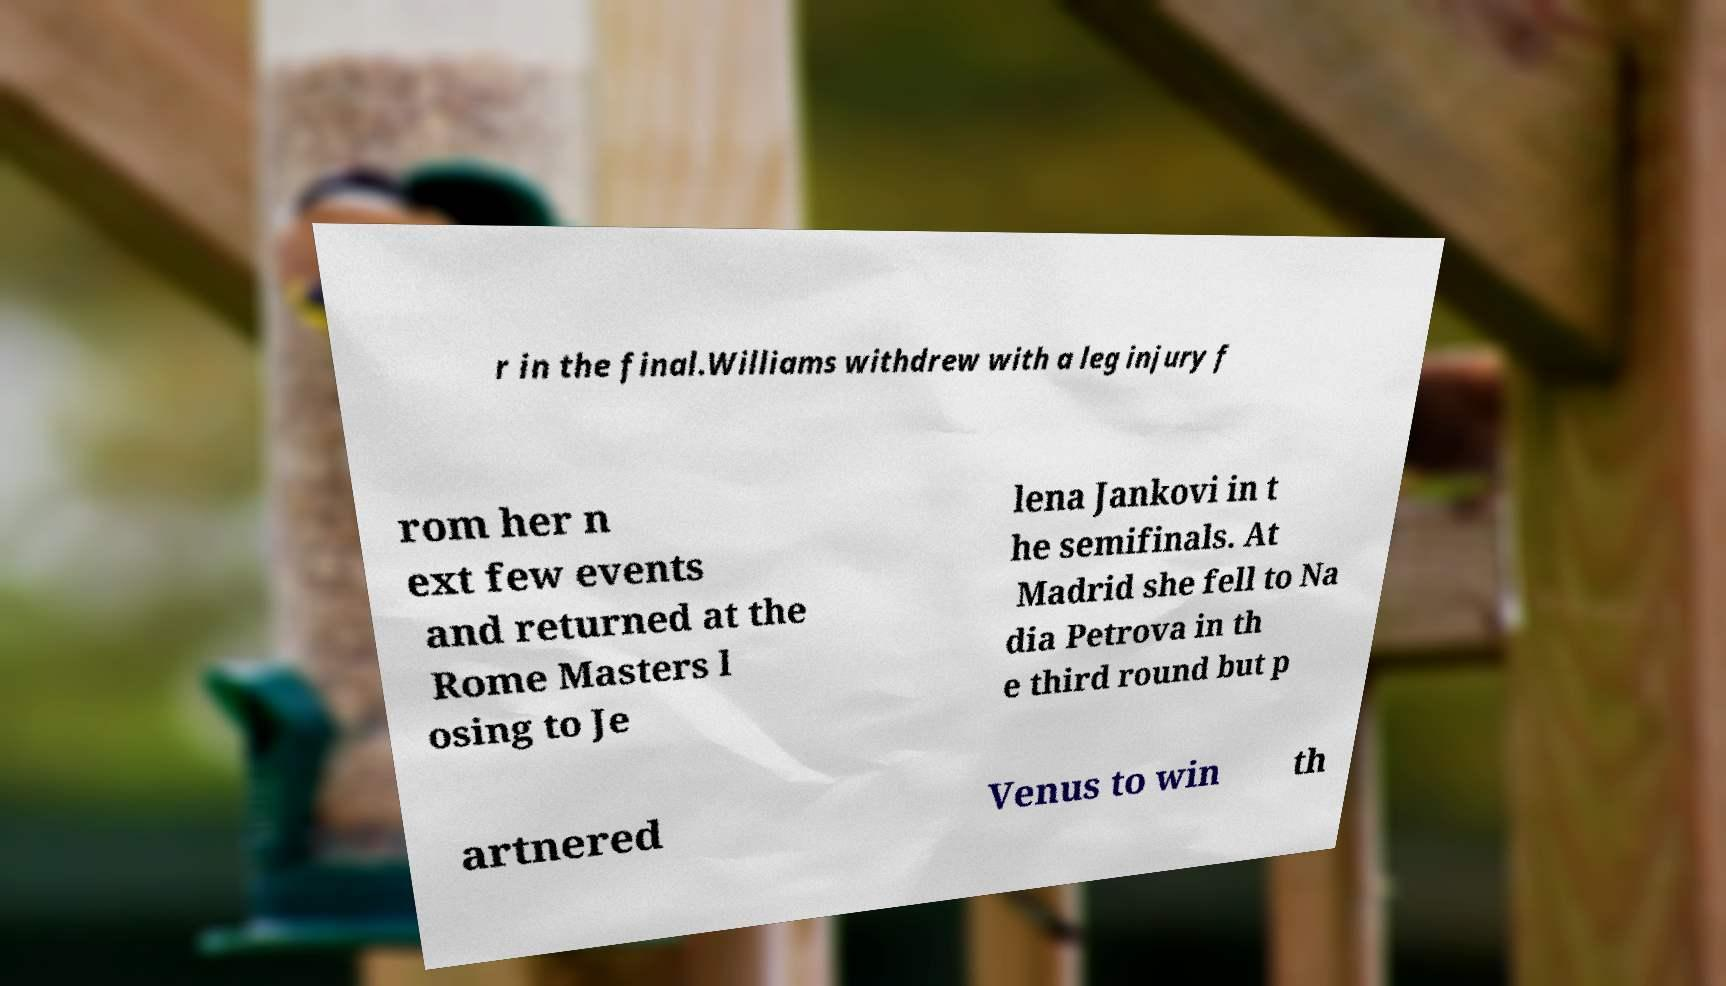Could you extract and type out the text from this image? r in the final.Williams withdrew with a leg injury f rom her n ext few events and returned at the Rome Masters l osing to Je lena Jankovi in t he semifinals. At Madrid she fell to Na dia Petrova in th e third round but p artnered Venus to win th 